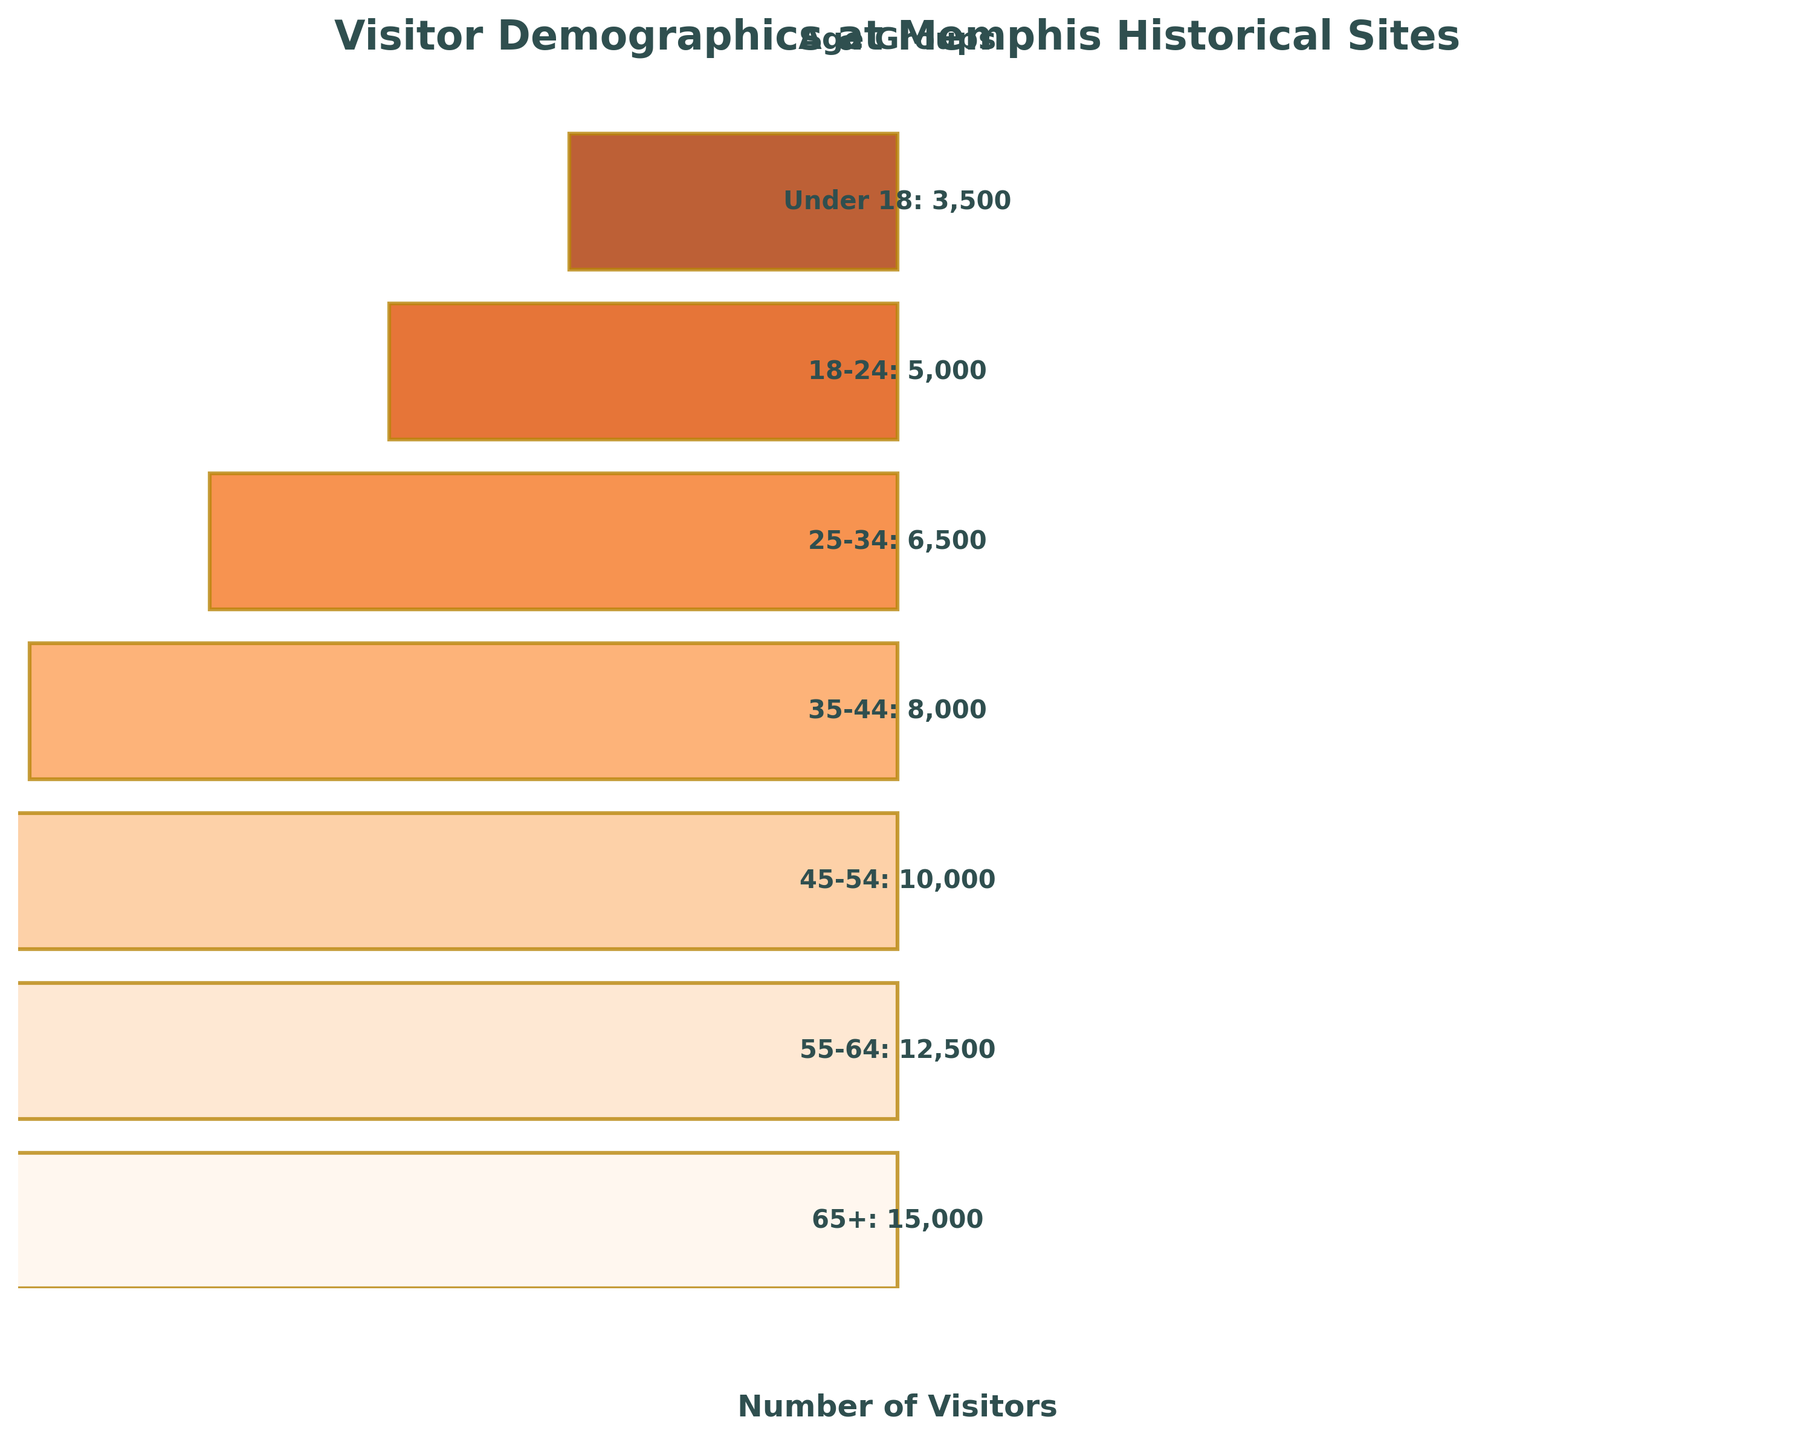Which age group has the highest number of visitors? To determine the age group with the highest number of visitors, look for the largest segment at the top of the funnel. According to the data, the "65+" age group has the highest number of visitors.
Answer: 65+ What is the title of the figure? The title of the figure is positioned at the top and states the overall theme of the visualization. Here, it is "Visitor Demographics at Memphis Historical Sites".
Answer: Visitor Demographics at Memphis Historical Sites How many visitors are there in the "45-54" age group? Refer to the funnel segment labeled "45-54" to find the number of visitors associated with that age group. According to the data provided, there are 10,000 visitors in the "45-54" age group.
Answer: 10,000 Which age group has fewer visitors: "18-24" or "35-44"? Compare the heights corresponding to the segments labeled "18-24" and "35-44". The "18-24" age group has 5,000 visitors, while the "35-44" has 8,000 visitors.
Answer: 18-24 What's the difference in the number of visitors between the "25-34" and "Under 18" age groups? Subtract the number of visitors in the "Under 18" age group from those in the "25-34" age group. According to the data, the difference is 6,500 - 3,500 = 3,000.
Answer: 3,000 How many segments are there in the funnel chart? Count the number of horizontal segments that make up the funnel. From the data provided, there are a total of seven segments representing different age groups.
Answer: Seven What is the visitor count for the two oldest age groups combined? Add the number of visitors for the "55-64" and "65+" age groups. From the data, it is 12,500 + 15,000 = 27,000.
Answer: 27,000 Which age group has a higher number of visitors, "55-64" or "35-44"? Compare the number of visitors for the "55-64" and "35-44" age groups. According to the data, the "55-64" age group has 12,500 visitors and the "35-44" age group has 8,000 visitors.
Answer: 55-64 What is the combined number of visitors for all age groups under 35? Add the number of visitors for the "Under 18", "18-24", and "25-34" age groups. The combined total is 3,500 + 5,000 + 6,500 = 15,000.
Answer: 15,000 Which age group has the smallest number of visitors? Identify the segment that appears smallest at the bottom of the funnel and confirm it with the data provided. The "Under 18" age group has the smallest number of visitors at 3,500.
Answer: Under 18 